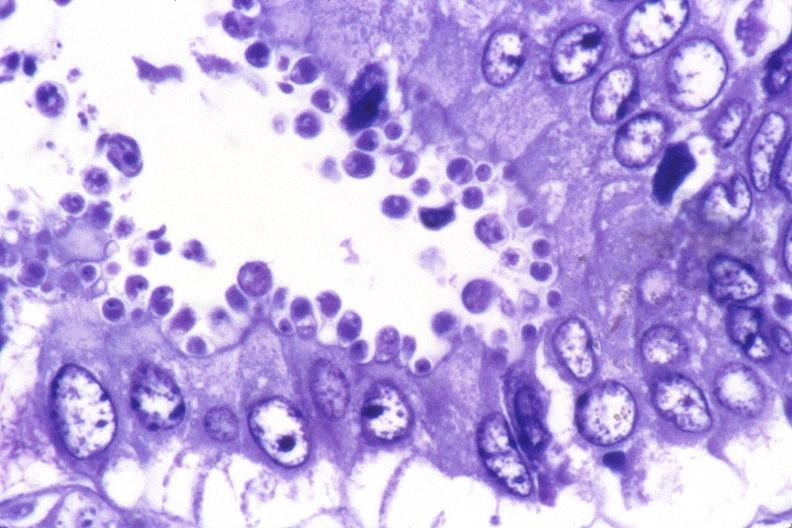does this image show colon, cryptosporidia?
Answer the question using a single word or phrase. Yes 